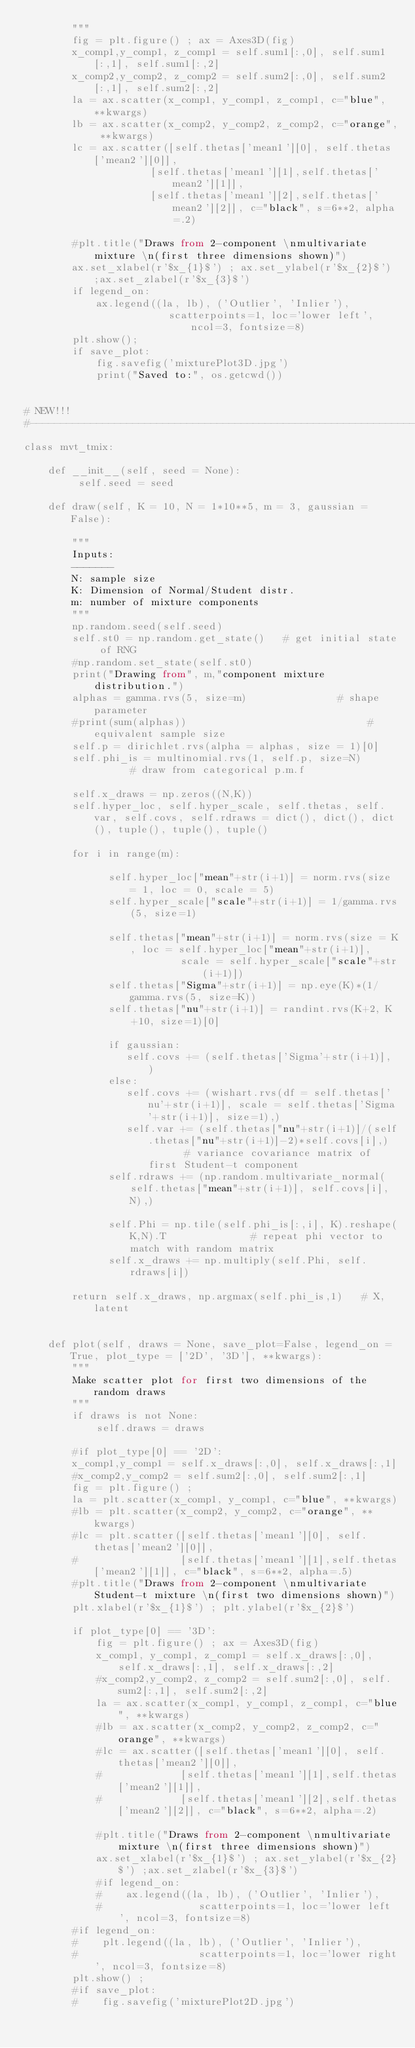Convert code to text. <code><loc_0><loc_0><loc_500><loc_500><_Python_>        """
        fig = plt.figure() ; ax = Axes3D(fig)
        x_comp1,y_comp1, z_comp1 = self.sum1[:,0], self.sum1[:,1], self.sum1[:,2]
        x_comp2,y_comp2, z_comp2 = self.sum2[:,0], self.sum2[:,1], self.sum2[:,2]
        la = ax.scatter(x_comp1, y_comp1, z_comp1, c="blue", **kwargs) 
        lb = ax.scatter(x_comp2, y_comp2, z_comp2, c="orange", **kwargs)  
        lc = ax.scatter([self.thetas['mean1'][0], self.thetas['mean2'][0]], 
                     [self.thetas['mean1'][1],self.thetas['mean2'][1]], 
                     [self.thetas['mean1'][2],self.thetas['mean2'][2]], c="black", s=6**2, alpha=.2)

        #plt.title("Draws from 2-component \nmultivariate mixture \n(first three dimensions shown)")
        ax.set_xlabel(r'$x_{1}$') ; ax.set_ylabel(r'$x_{2}$') ;ax.set_zlabel(r'$x_{3}$')
        if legend_on:
            ax.legend((la, lb), ('Outlier', 'Inlier'),
                        scatterpoints=1, loc='lower left', ncol=3, fontsize=8)    
        plt.show();
        if save_plot:
            fig.savefig('mixturePlot3D.jpg')
            print("Saved to:", os.getcwd())


# NEW!!!
#-------------------------------------------------------------------------------------
class mvt_tmix:
    
    def __init__(self, seed = None):
         self.seed = seed
    
    def draw(self, K = 10, N = 1*10**5, m = 3, gaussian = False):
        
        """
        Inputs:
        -------
        N: sample size
        K: Dimension of Normal/Student distr.
        m: number of mixture components
        """
        np.random.seed(self.seed)     
        self.st0 = np.random.get_state()   # get initial state of RNG
        #np.random.set_state(self.st0)
        print("Drawing from", m,"component mixture distribution.")
        alphas = gamma.rvs(5, size=m)               # shape parameter
        #print(sum(alphas))                              # equivalent sample size
        self.p = dirichlet.rvs(alpha = alphas, size = 1)[0]
        self.phi_is = multinomial.rvs(1, self.p, size=N)       # draw from categorical p.m.f
        
        self.x_draws = np.zeros((N,K))
        self.hyper_loc, self.hyper_scale, self.thetas, self.var, self.covs, self.rdraws = dict(), dict(), dict(), tuple(), tuple(), tuple()
        
        for i in range(m):
        
              self.hyper_loc["mean"+str(i+1)] = norm.rvs(size = 1, loc = 0, scale = 5)
              self.hyper_scale["scale"+str(i+1)] = 1/gamma.rvs(5, size=1)
              
              self.thetas["mean"+str(i+1)] = norm.rvs(size = K, loc = self.hyper_loc["mean"+str(i+1)], 
                          scale = self.hyper_scale["scale"+str(i+1)])
              self.thetas["Sigma"+str(i+1)] = np.eye(K)*(1/gamma.rvs(5, size=K))
              self.thetas["nu"+str(i+1)] = randint.rvs(K+2, K+10, size=1)[0]
        
              if gaussian:
                 self.covs += (self.thetas['Sigma'+str(i+1)], )
              else:
                 self.covs += (wishart.rvs(df = self.thetas['nu'+str(i+1)], scale = self.thetas['Sigma'+str(i+1)], size=1),)
                 self.var += (self.thetas["nu"+str(i+1)]/(self.thetas["nu"+str(i+1)]-2)*self.covs[i],)       # variance covariance matrix of first Student-t component
              self.rdraws += (np.random.multivariate_normal(self.thetas["mean"+str(i+1)], self.covs[i], N),)
        
              self.Phi = np.tile(self.phi_is[:,i], K).reshape(K,N).T              # repeat phi vector to match with random matrix
              self.x_draws += np.multiply(self.Phi, self.rdraws[i])          
              
        return self.x_draws, np.argmax(self.phi_is,1)   # X, latent


    def plot(self, draws = None, save_plot=False, legend_on = True, plot_type = ['2D', '3D'], **kwargs):
        """
        Make scatter plot for first two dimensions of the random draws
        """
        if draws is not None:
            self.draws = draws
            
        #if plot_type[0] == '2D':
        x_comp1,y_comp1 = self.x_draws[:,0], self.x_draws[:,1]
        #x_comp2,y_comp2 = self.sum2[:,0], self.sum2[:,1]
        fig = plt.figure() ; 
        la = plt.scatter(x_comp1, y_comp1, c="blue", **kwargs)
        #lb = plt.scatter(x_comp2, y_comp2, c="orange", **kwargs)
        #lc = plt.scatter([self.thetas['mean1'][0], self.thetas['mean2'][0]], 
        #                 [self.thetas['mean1'][1],self.thetas['mean2'][1]], c="black", s=6**2, alpha=.5)
        #plt.title("Draws from 2-component \nmultivariate Student-t mixture \n(first two dimensions shown)")
        plt.xlabel(r'$x_{1}$') ; plt.ylabel(r'$x_{2}$')
        
        if plot_type[0] == '3D':
            fig = plt.figure() ; ax = Axes3D(fig)
            x_comp1, y_comp1, z_comp1 = self.x_draws[:,0], self.x_draws[:,1], self.x_draws[:,2]
            #x_comp2,y_comp2, z_comp2 = self.sum2[:,0], self.sum2[:,1], self.sum2[:,2]
            la = ax.scatter(x_comp1, y_comp1, z_comp1, c="blue", **kwargs) 
            #lb = ax.scatter(x_comp2, y_comp2, z_comp2, c="orange", **kwargs)  
            #lc = ax.scatter([self.thetas['mean1'][0], self.thetas['mean2'][0]], 
            #             [self.thetas['mean1'][1],self.thetas['mean2'][1]], 
            #             [self.thetas['mean1'][2],self.thetas['mean2'][2]], c="black", s=6**2, alpha=.2)
    
            #plt.title("Draws from 2-component \nmultivariate mixture \n(first three dimensions shown)")
            ax.set_xlabel(r'$x_{1}$') ; ax.set_ylabel(r'$x_{2}$') ;ax.set_zlabel(r'$x_{3}$')
            #if legend_on:
            #    ax.legend((la, lb), ('Outlier', 'Inlier'),
            #                scatterpoints=1, loc='lower left', ncol=3, fontsize=8)                            
        #if legend_on:
        #    plt.legend((la, lb), ('Outlier', 'Inlier'),
        #                    scatterpoints=1, loc='lower right', ncol=3, fontsize=8)
        plt.show() ;
        #if save_plot:
        #    fig.savefig('mixturePlot2D.jpg')</code> 